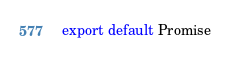<code> <loc_0><loc_0><loc_500><loc_500><_JavaScript_>export default Promise</code> 